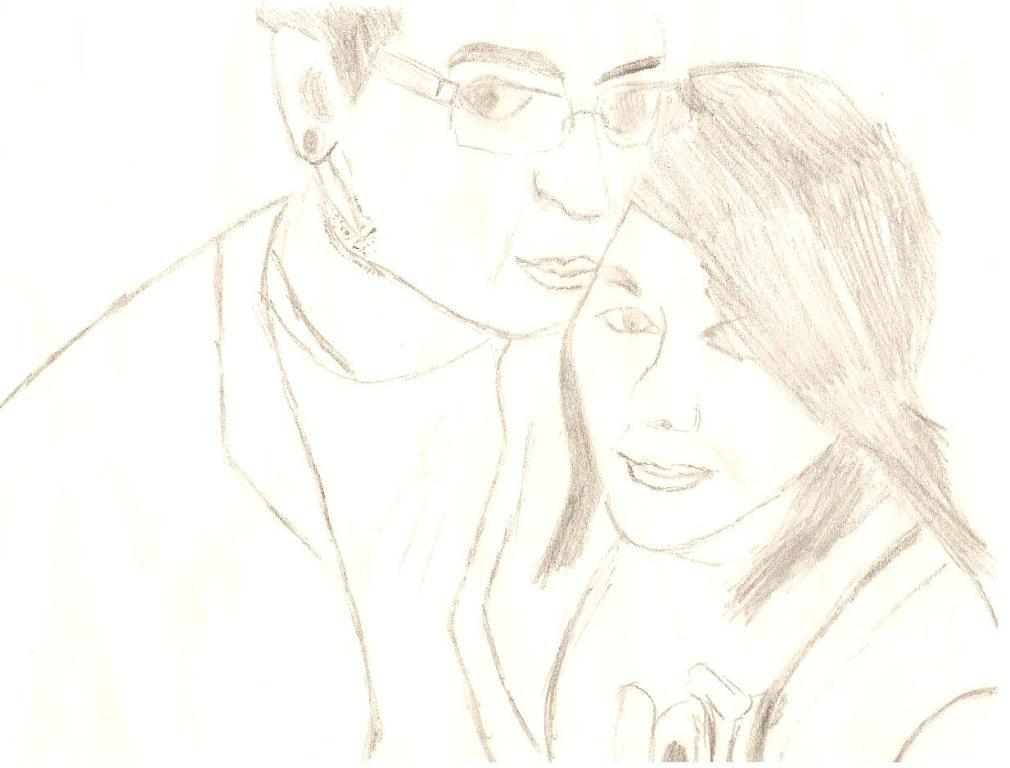What type of figures are depicted in the image? There is a drawing of a man and a woman in the image. Can you describe the subjects of the drawing? The drawing features a man and a woman. What is the purpose of the square in the image? There is no square present in the image. How often do the figures in the image wash their hands? The image does not depict any action or activity, such as washing hands, so it cannot be determined from the image. 